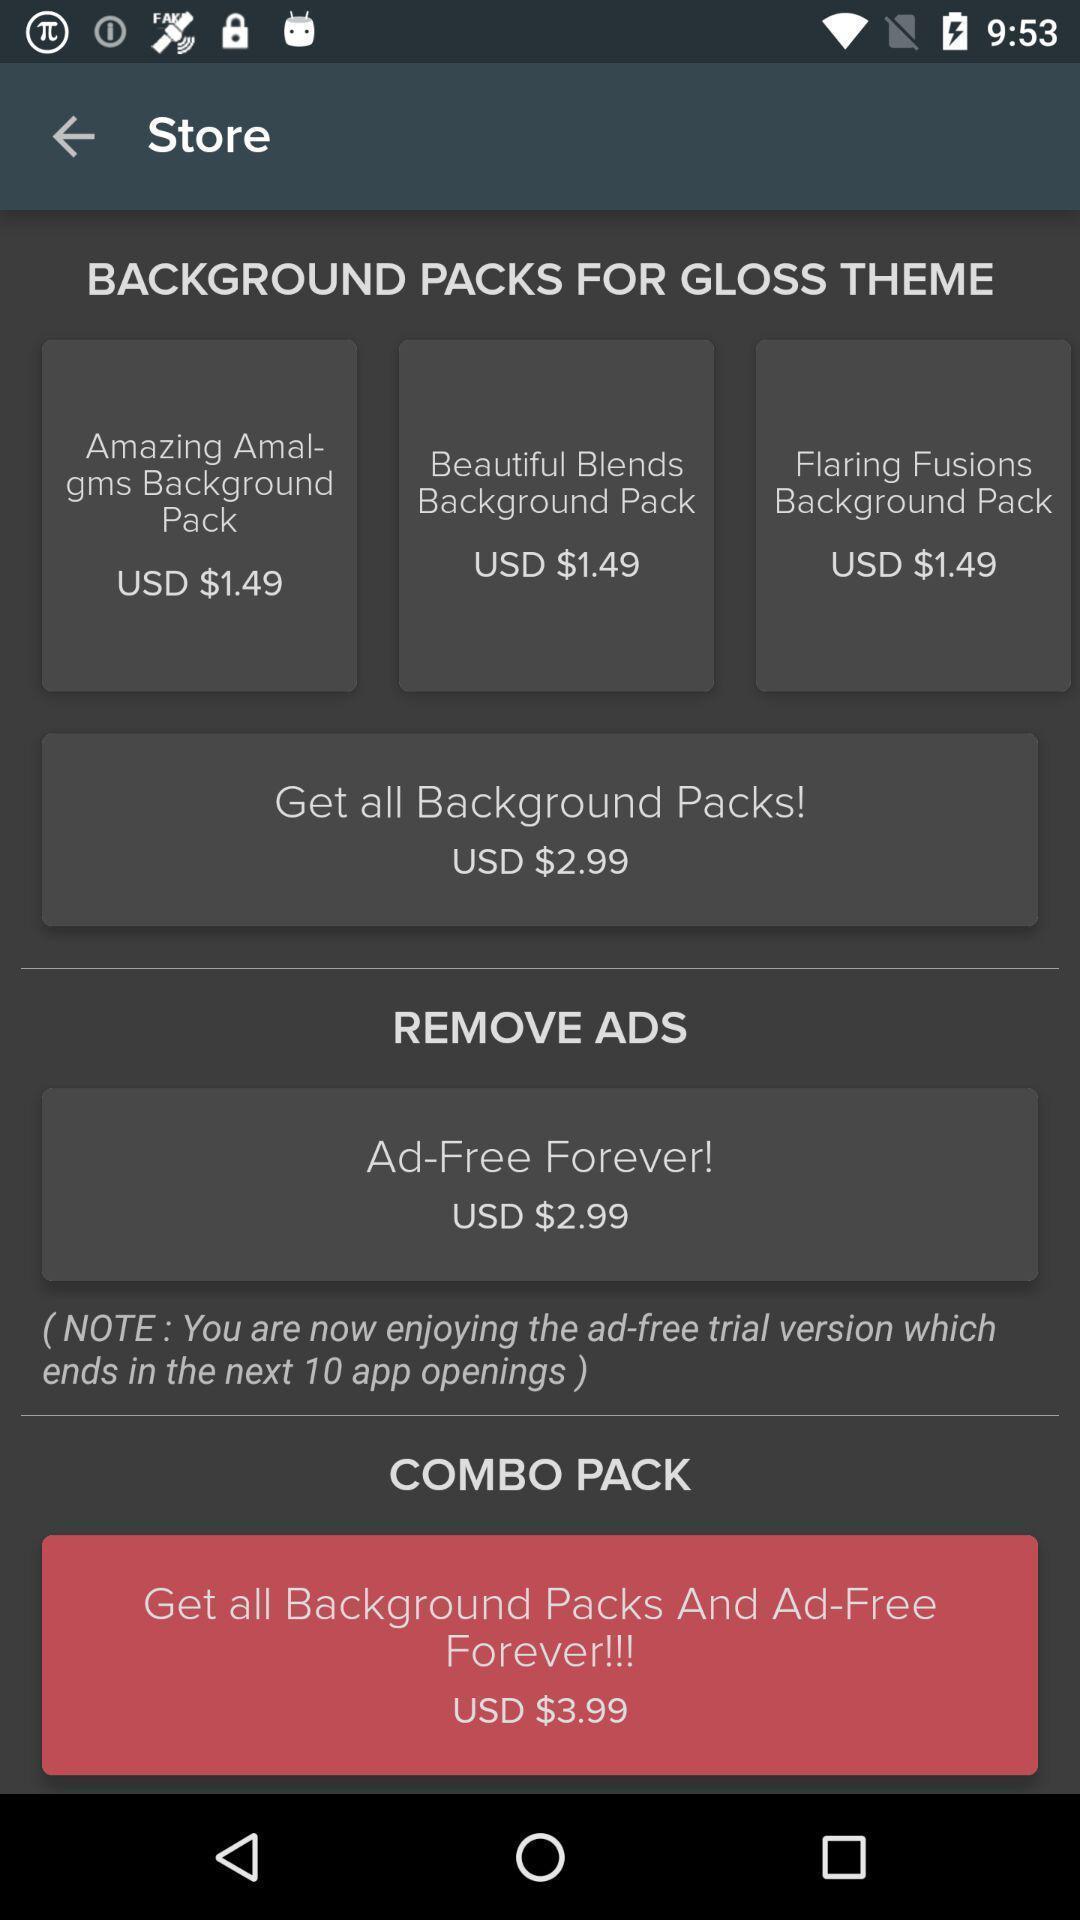Give me a narrative description of this picture. Page showing different packs on a musical app. 